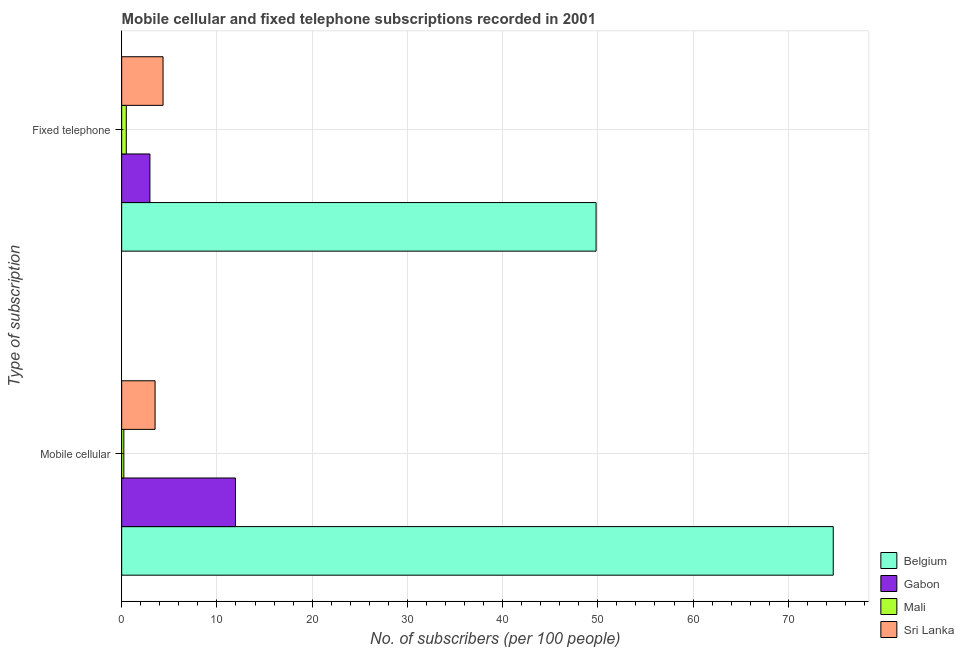Are the number of bars on each tick of the Y-axis equal?
Provide a short and direct response. Yes. How many bars are there on the 1st tick from the top?
Provide a succinct answer. 4. What is the label of the 2nd group of bars from the top?
Keep it short and to the point. Mobile cellular. What is the number of fixed telephone subscribers in Sri Lanka?
Provide a short and direct response. 4.35. Across all countries, what is the maximum number of fixed telephone subscribers?
Your answer should be very brief. 49.82. Across all countries, what is the minimum number of fixed telephone subscribers?
Your response must be concise. 0.48. In which country was the number of fixed telephone subscribers minimum?
Make the answer very short. Mali. What is the total number of fixed telephone subscribers in the graph?
Your answer should be very brief. 57.61. What is the difference between the number of mobile cellular subscribers in Belgium and that in Sri Lanka?
Your answer should be compact. 71.22. What is the difference between the number of mobile cellular subscribers in Mali and the number of fixed telephone subscribers in Gabon?
Your answer should be compact. -2.74. What is the average number of fixed telephone subscribers per country?
Keep it short and to the point. 14.4. What is the difference between the number of fixed telephone subscribers and number of mobile cellular subscribers in Gabon?
Offer a very short reply. -8.98. What is the ratio of the number of mobile cellular subscribers in Mali to that in Sri Lanka?
Provide a succinct answer. 0.06. Is the number of fixed telephone subscribers in Sri Lanka less than that in Gabon?
Provide a short and direct response. No. What does the 1st bar from the top in Fixed telephone represents?
Your response must be concise. Sri Lanka. What does the 1st bar from the bottom in Mobile cellular represents?
Offer a very short reply. Belgium. Are all the bars in the graph horizontal?
Offer a very short reply. Yes. How many countries are there in the graph?
Give a very brief answer. 4. Does the graph contain grids?
Ensure brevity in your answer.  Yes. How many legend labels are there?
Offer a terse response. 4. What is the title of the graph?
Give a very brief answer. Mobile cellular and fixed telephone subscriptions recorded in 2001. Does "OECD members" appear as one of the legend labels in the graph?
Make the answer very short. No. What is the label or title of the X-axis?
Offer a terse response. No. of subscribers (per 100 people). What is the label or title of the Y-axis?
Offer a very short reply. Type of subscription. What is the No. of subscribers (per 100 people) of Belgium in Mobile cellular?
Make the answer very short. 74.72. What is the No. of subscribers (per 100 people) of Gabon in Mobile cellular?
Your answer should be very brief. 11.95. What is the No. of subscribers (per 100 people) in Mali in Mobile cellular?
Offer a very short reply. 0.23. What is the No. of subscribers (per 100 people) of Sri Lanka in Mobile cellular?
Provide a short and direct response. 3.51. What is the No. of subscribers (per 100 people) of Belgium in Fixed telephone?
Ensure brevity in your answer.  49.82. What is the No. of subscribers (per 100 people) of Gabon in Fixed telephone?
Offer a terse response. 2.97. What is the No. of subscribers (per 100 people) of Mali in Fixed telephone?
Keep it short and to the point. 0.48. What is the No. of subscribers (per 100 people) of Sri Lanka in Fixed telephone?
Keep it short and to the point. 4.35. Across all Type of subscription, what is the maximum No. of subscribers (per 100 people) of Belgium?
Offer a very short reply. 74.72. Across all Type of subscription, what is the maximum No. of subscribers (per 100 people) of Gabon?
Keep it short and to the point. 11.95. Across all Type of subscription, what is the maximum No. of subscribers (per 100 people) in Mali?
Offer a terse response. 0.48. Across all Type of subscription, what is the maximum No. of subscribers (per 100 people) of Sri Lanka?
Your answer should be very brief. 4.35. Across all Type of subscription, what is the minimum No. of subscribers (per 100 people) of Belgium?
Your answer should be very brief. 49.82. Across all Type of subscription, what is the minimum No. of subscribers (per 100 people) of Gabon?
Offer a very short reply. 2.97. Across all Type of subscription, what is the minimum No. of subscribers (per 100 people) of Mali?
Your answer should be compact. 0.23. Across all Type of subscription, what is the minimum No. of subscribers (per 100 people) of Sri Lanka?
Offer a terse response. 3.51. What is the total No. of subscribers (per 100 people) of Belgium in the graph?
Your answer should be very brief. 124.54. What is the total No. of subscribers (per 100 people) in Gabon in the graph?
Keep it short and to the point. 14.92. What is the total No. of subscribers (per 100 people) in Mali in the graph?
Provide a short and direct response. 0.71. What is the total No. of subscribers (per 100 people) of Sri Lanka in the graph?
Your answer should be compact. 7.85. What is the difference between the No. of subscribers (per 100 people) in Belgium in Mobile cellular and that in Fixed telephone?
Give a very brief answer. 24.9. What is the difference between the No. of subscribers (per 100 people) in Gabon in Mobile cellular and that in Fixed telephone?
Your answer should be compact. 8.98. What is the difference between the No. of subscribers (per 100 people) of Mali in Mobile cellular and that in Fixed telephone?
Make the answer very short. -0.26. What is the difference between the No. of subscribers (per 100 people) of Sri Lanka in Mobile cellular and that in Fixed telephone?
Your response must be concise. -0.84. What is the difference between the No. of subscribers (per 100 people) of Belgium in Mobile cellular and the No. of subscribers (per 100 people) of Gabon in Fixed telephone?
Provide a succinct answer. 71.76. What is the difference between the No. of subscribers (per 100 people) in Belgium in Mobile cellular and the No. of subscribers (per 100 people) in Mali in Fixed telephone?
Give a very brief answer. 74.24. What is the difference between the No. of subscribers (per 100 people) in Belgium in Mobile cellular and the No. of subscribers (per 100 people) in Sri Lanka in Fixed telephone?
Offer a very short reply. 70.38. What is the difference between the No. of subscribers (per 100 people) of Gabon in Mobile cellular and the No. of subscribers (per 100 people) of Mali in Fixed telephone?
Provide a succinct answer. 11.47. What is the difference between the No. of subscribers (per 100 people) of Gabon in Mobile cellular and the No. of subscribers (per 100 people) of Sri Lanka in Fixed telephone?
Offer a very short reply. 7.6. What is the difference between the No. of subscribers (per 100 people) in Mali in Mobile cellular and the No. of subscribers (per 100 people) in Sri Lanka in Fixed telephone?
Your answer should be compact. -4.12. What is the average No. of subscribers (per 100 people) of Belgium per Type of subscription?
Ensure brevity in your answer.  62.27. What is the average No. of subscribers (per 100 people) in Gabon per Type of subscription?
Your answer should be compact. 7.46. What is the average No. of subscribers (per 100 people) in Mali per Type of subscription?
Offer a very short reply. 0.36. What is the average No. of subscribers (per 100 people) in Sri Lanka per Type of subscription?
Ensure brevity in your answer.  3.93. What is the difference between the No. of subscribers (per 100 people) of Belgium and No. of subscribers (per 100 people) of Gabon in Mobile cellular?
Offer a terse response. 62.77. What is the difference between the No. of subscribers (per 100 people) in Belgium and No. of subscribers (per 100 people) in Mali in Mobile cellular?
Your answer should be very brief. 74.5. What is the difference between the No. of subscribers (per 100 people) of Belgium and No. of subscribers (per 100 people) of Sri Lanka in Mobile cellular?
Your answer should be compact. 71.22. What is the difference between the No. of subscribers (per 100 people) of Gabon and No. of subscribers (per 100 people) of Mali in Mobile cellular?
Give a very brief answer. 11.72. What is the difference between the No. of subscribers (per 100 people) in Gabon and No. of subscribers (per 100 people) in Sri Lanka in Mobile cellular?
Provide a short and direct response. 8.44. What is the difference between the No. of subscribers (per 100 people) of Mali and No. of subscribers (per 100 people) of Sri Lanka in Mobile cellular?
Your answer should be compact. -3.28. What is the difference between the No. of subscribers (per 100 people) in Belgium and No. of subscribers (per 100 people) in Gabon in Fixed telephone?
Keep it short and to the point. 46.85. What is the difference between the No. of subscribers (per 100 people) in Belgium and No. of subscribers (per 100 people) in Mali in Fixed telephone?
Offer a terse response. 49.34. What is the difference between the No. of subscribers (per 100 people) in Belgium and No. of subscribers (per 100 people) in Sri Lanka in Fixed telephone?
Offer a very short reply. 45.47. What is the difference between the No. of subscribers (per 100 people) of Gabon and No. of subscribers (per 100 people) of Mali in Fixed telephone?
Your answer should be very brief. 2.48. What is the difference between the No. of subscribers (per 100 people) in Gabon and No. of subscribers (per 100 people) in Sri Lanka in Fixed telephone?
Keep it short and to the point. -1.38. What is the difference between the No. of subscribers (per 100 people) of Mali and No. of subscribers (per 100 people) of Sri Lanka in Fixed telephone?
Offer a terse response. -3.86. What is the ratio of the No. of subscribers (per 100 people) in Belgium in Mobile cellular to that in Fixed telephone?
Offer a very short reply. 1.5. What is the ratio of the No. of subscribers (per 100 people) of Gabon in Mobile cellular to that in Fixed telephone?
Offer a very short reply. 4.03. What is the ratio of the No. of subscribers (per 100 people) of Mali in Mobile cellular to that in Fixed telephone?
Your response must be concise. 0.47. What is the ratio of the No. of subscribers (per 100 people) of Sri Lanka in Mobile cellular to that in Fixed telephone?
Offer a very short reply. 0.81. What is the difference between the highest and the second highest No. of subscribers (per 100 people) in Belgium?
Provide a short and direct response. 24.9. What is the difference between the highest and the second highest No. of subscribers (per 100 people) in Gabon?
Provide a succinct answer. 8.98. What is the difference between the highest and the second highest No. of subscribers (per 100 people) in Mali?
Make the answer very short. 0.26. What is the difference between the highest and the second highest No. of subscribers (per 100 people) in Sri Lanka?
Your answer should be compact. 0.84. What is the difference between the highest and the lowest No. of subscribers (per 100 people) in Belgium?
Make the answer very short. 24.9. What is the difference between the highest and the lowest No. of subscribers (per 100 people) in Gabon?
Your answer should be compact. 8.98. What is the difference between the highest and the lowest No. of subscribers (per 100 people) in Mali?
Offer a terse response. 0.26. What is the difference between the highest and the lowest No. of subscribers (per 100 people) of Sri Lanka?
Offer a very short reply. 0.84. 